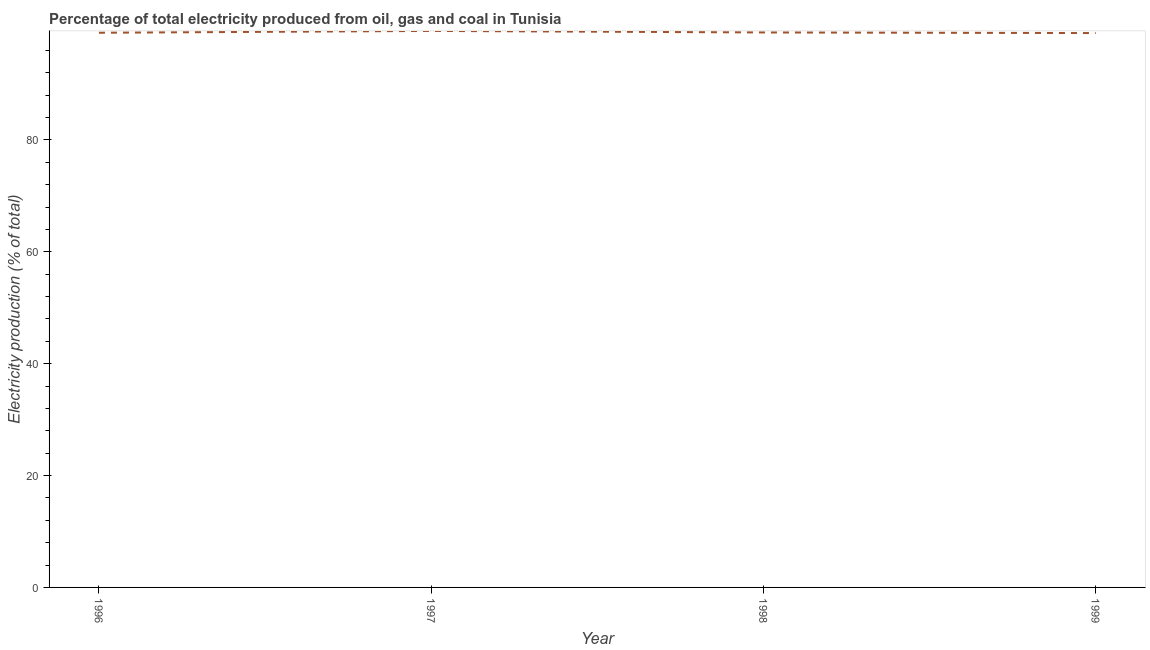What is the electricity production in 1997?
Give a very brief answer. 99.48. Across all years, what is the maximum electricity production?
Your answer should be compact. 99.48. Across all years, what is the minimum electricity production?
Offer a terse response. 99.1. In which year was the electricity production maximum?
Give a very brief answer. 1997. In which year was the electricity production minimum?
Provide a short and direct response. 1999. What is the sum of the electricity production?
Ensure brevity in your answer.  396.94. What is the difference between the electricity production in 1996 and 1999?
Offer a very short reply. 0.06. What is the average electricity production per year?
Offer a very short reply. 99.24. What is the median electricity production?
Provide a short and direct response. 99.18. What is the ratio of the electricity production in 1997 to that in 1998?
Your answer should be compact. 1. Is the electricity production in 1996 less than that in 1999?
Your answer should be very brief. No. What is the difference between the highest and the second highest electricity production?
Your answer should be compact. 0.27. Is the sum of the electricity production in 1997 and 1999 greater than the maximum electricity production across all years?
Offer a very short reply. Yes. What is the difference between the highest and the lowest electricity production?
Give a very brief answer. 0.38. In how many years, is the electricity production greater than the average electricity production taken over all years?
Make the answer very short. 1. Does the electricity production monotonically increase over the years?
Offer a very short reply. No. Does the graph contain grids?
Keep it short and to the point. No. What is the title of the graph?
Offer a terse response. Percentage of total electricity produced from oil, gas and coal in Tunisia. What is the label or title of the Y-axis?
Offer a very short reply. Electricity production (% of total). What is the Electricity production (% of total) of 1996?
Give a very brief answer. 99.15. What is the Electricity production (% of total) in 1997?
Provide a short and direct response. 99.48. What is the Electricity production (% of total) in 1998?
Provide a succinct answer. 99.21. What is the Electricity production (% of total) in 1999?
Offer a terse response. 99.1. What is the difference between the Electricity production (% of total) in 1996 and 1997?
Ensure brevity in your answer.  -0.33. What is the difference between the Electricity production (% of total) in 1996 and 1998?
Give a very brief answer. -0.05. What is the difference between the Electricity production (% of total) in 1996 and 1999?
Offer a terse response. 0.06. What is the difference between the Electricity production (% of total) in 1997 and 1998?
Provide a short and direct response. 0.27. What is the difference between the Electricity production (% of total) in 1997 and 1999?
Your answer should be very brief. 0.38. What is the difference between the Electricity production (% of total) in 1998 and 1999?
Your response must be concise. 0.11. 